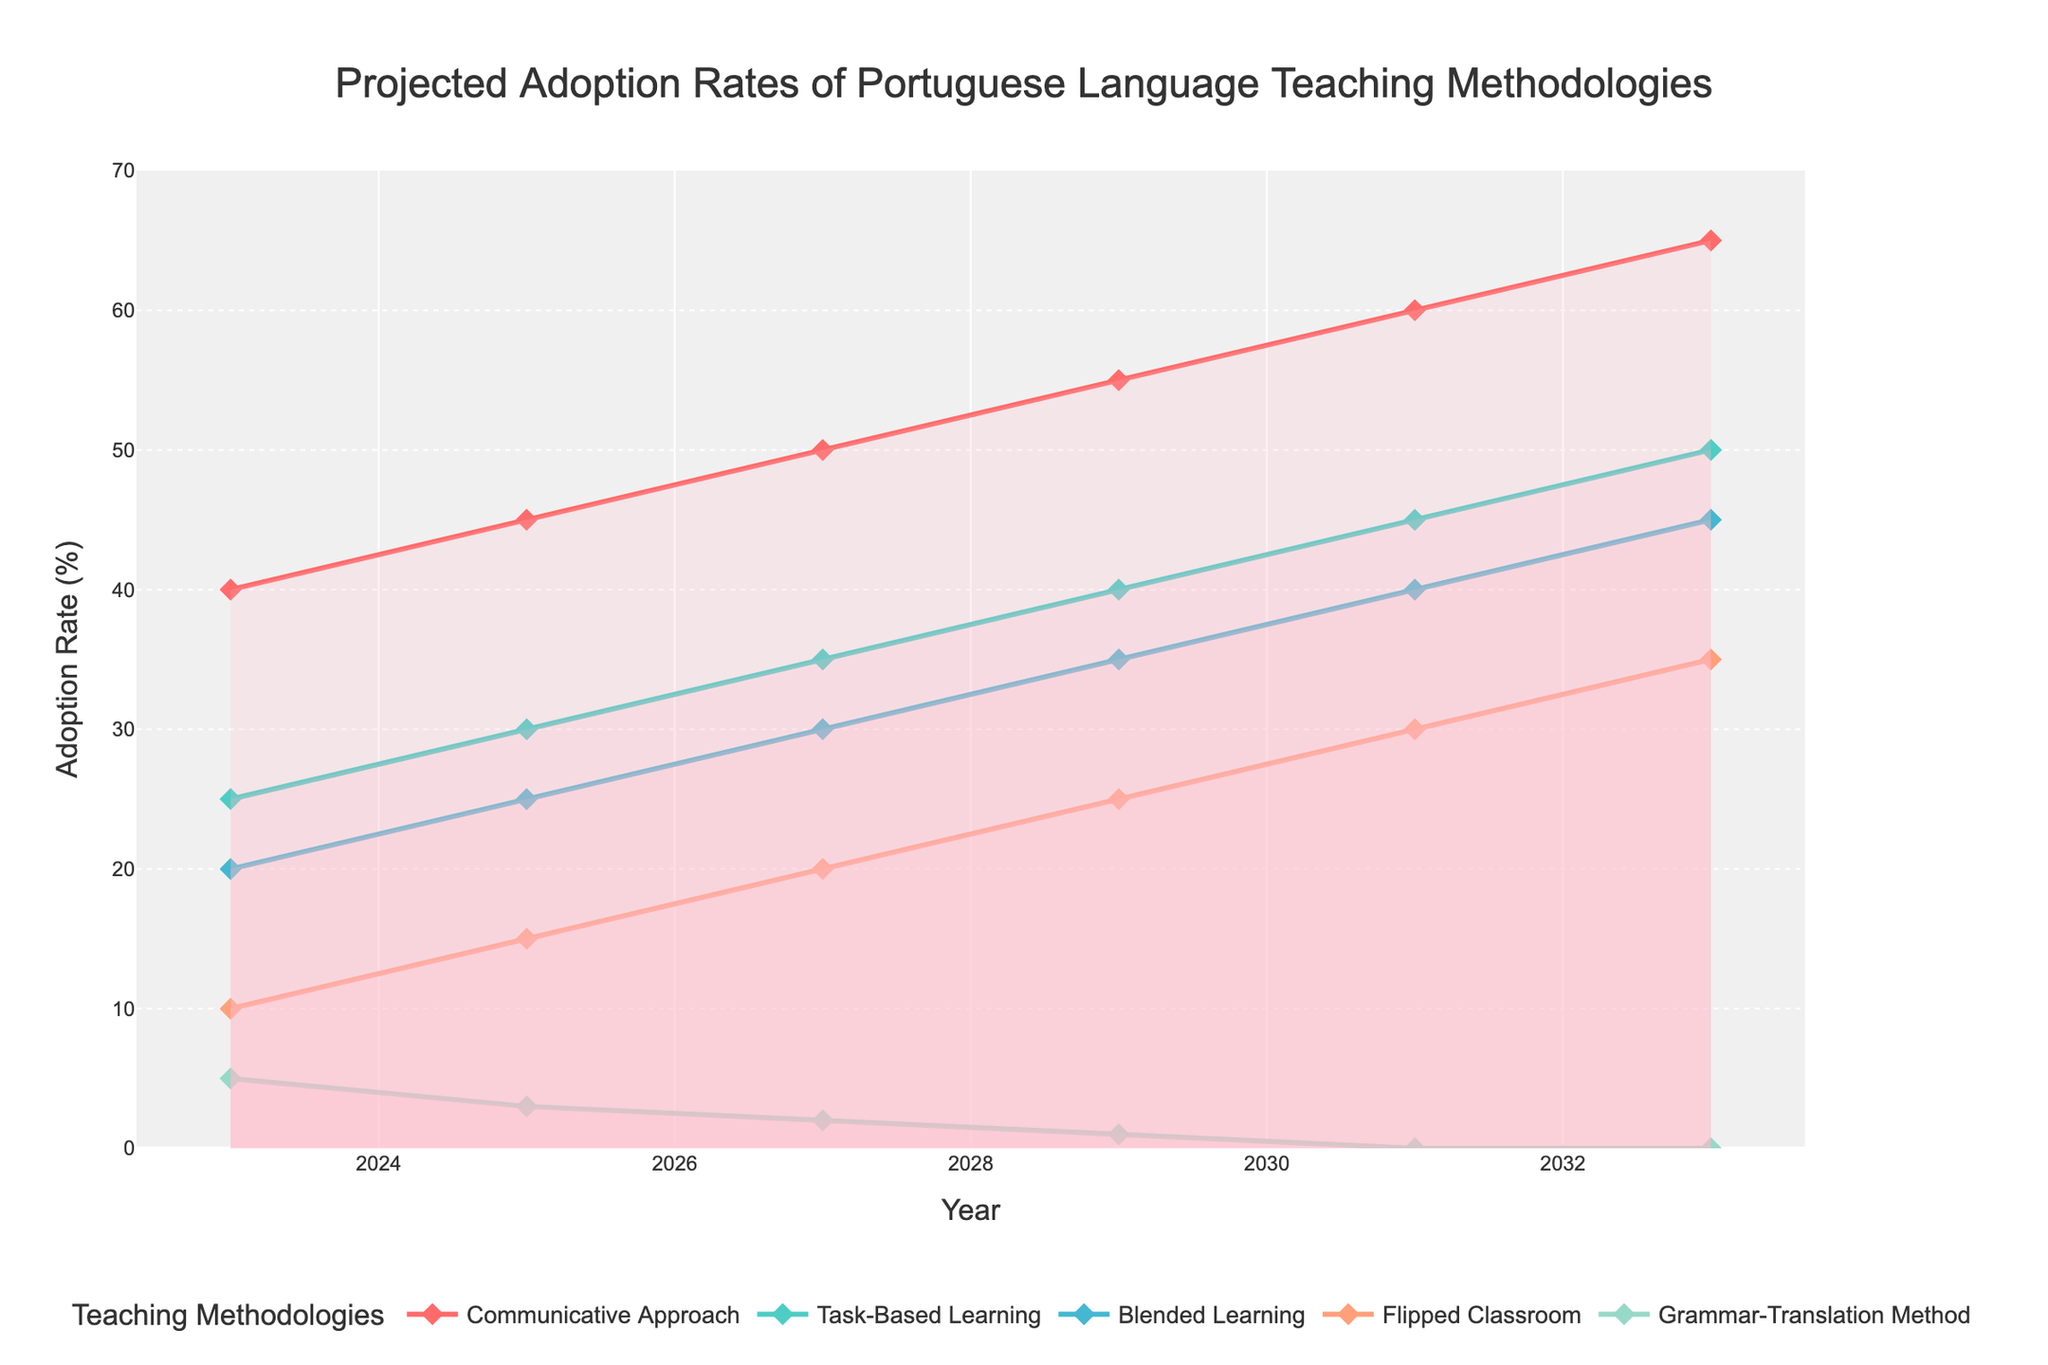What's the title of the chart? The title is located at the top of the chart. It reads 'Projected Adoption Rates of Portuguese Language Teaching Methodologies'.
Answer: Projected Adoption Rates of Portuguese Language Teaching Methodologies How many teaching methodologies are being projected in the chart? Count the number of lines or entries in the legend that correspond to different teaching methodologies. Each methodology is represented by a distinct line and legend item.
Answer: Five What is the adoption rate of the Communicative Approach in 2029? Locate the point for the year 2029 on the x-axis and find the corresponding y-value for the Communicative Approach line.
Answer: 55% Which methodology is expected to have the lowest adoption rate by 2033? Observe the trends of all methodologies over time and identify the one with the lowest value by the year 2033.
Answer: Grammar-Translation Method By how much is the adoption rate of Task-Based Learning expected to increase from 2023 to 2027? Find the adoption rates for Task-Based Learning in 2023 and 2027, then subtract the 2023 value from the 2027 value.
Answer: 10% Which methodologies are projected to exceed a 30% adoption rate by the year 2027? Check the y-axis values for each methodology in the year 2027 and identify those with adoption rates greater than 30%.
Answer: Communicative Approach, Task-Based Learning, Blended Learning What is the difference in the adoption rate between Blended Learning and Flipped Classroom in 2033? Find the adoption rates for both Blended Learning and Flipped Classroom in 2033, then compute the difference by subtracting the rate of Flipped Classroom from that of Blended Learning.
Answer: 10% Which methodology shows the most consistent increase in adoption rate over the 10-year period? Evaluate the general trends of all methodologies across the years. The one with the most consistent upward trend without fluctuation is the answer.
Answer: Communicative Approach Considering the projections, what is the combined adoption rate of Blended Learning and Flipped Classroom in 2025? Locate the adoption rates for both Blended Learning and Flipped Classroom in 2025 and sum them up.
Answer: 40% By 2033, which methodology is expected to be adopted by half of the schools? Identify the methodology with an adoption rate of 50% in the year 2033.
Answer: Task-Based Learning 